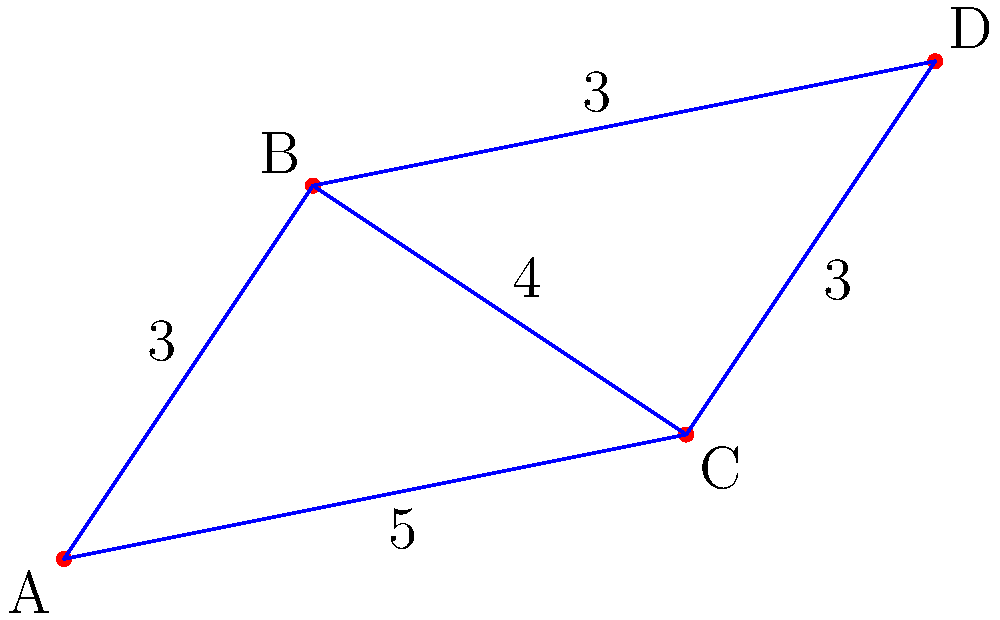In an assembly line, robotic arms move products between stations A, B, C, and D. The numbers on the paths represent the time (in seconds) taken by the robotic arm to move between stations. What is the minimum time required to move a product from station A to station D? To find the minimum time required to move a product from station A to station D, we need to consider all possible paths and calculate their total times:

1. Path A → B → D:
   Time = AB + BD = 3 + 3 = 6 seconds

2. Path A → C → D:
   Time = AC + CD = 5 + 3 = 8 seconds

3. Path A → B → C → D:
   Time = AB + BC + CD = 3 + 4 + 3 = 10 seconds

4. Path A → C → B → D:
   Time = AC + CB + BD = 5 + 4 + 3 = 12 seconds

Comparing all these paths, we can see that the shortest time is achieved through path A → B → D, which takes 6 seconds.
Answer: 6 seconds 